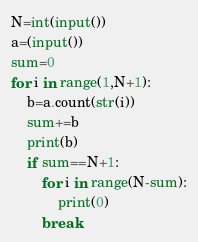Convert code to text. <code><loc_0><loc_0><loc_500><loc_500><_Python_>N=int(input())
a=(input())
sum=0
for i in range(1,N+1):
    b=a.count(str(i))
    sum+=b
    print(b)
    if sum==N+1:
        for i in range(N-sum):
            print(0)
        break</code> 